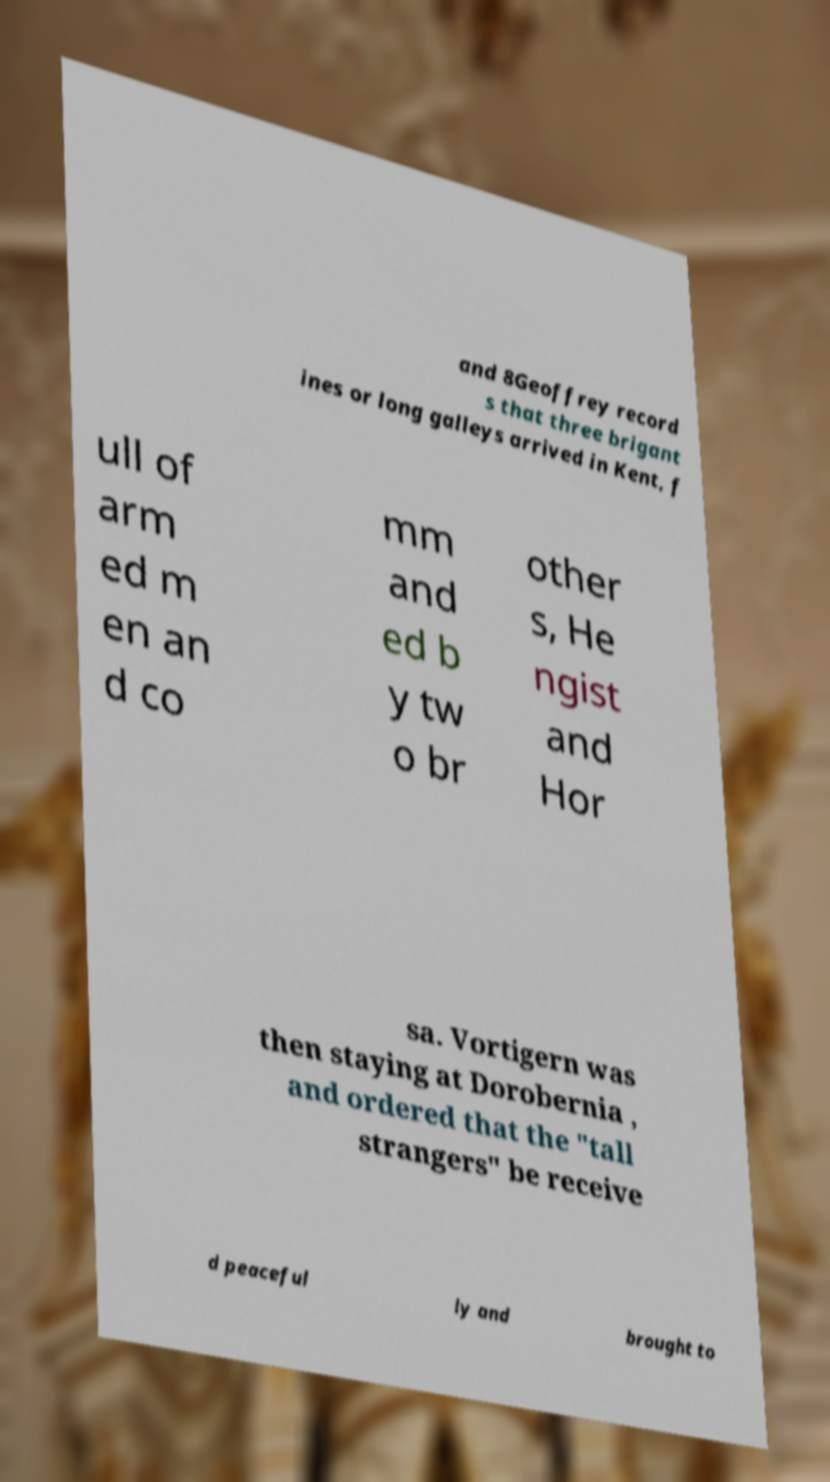Please identify and transcribe the text found in this image. and 8Geoffrey record s that three brigant ines or long galleys arrived in Kent, f ull of arm ed m en an d co mm and ed b y tw o br other s, He ngist and Hor sa. Vortigern was then staying at Dorobernia , and ordered that the "tall strangers" be receive d peaceful ly and brought to 